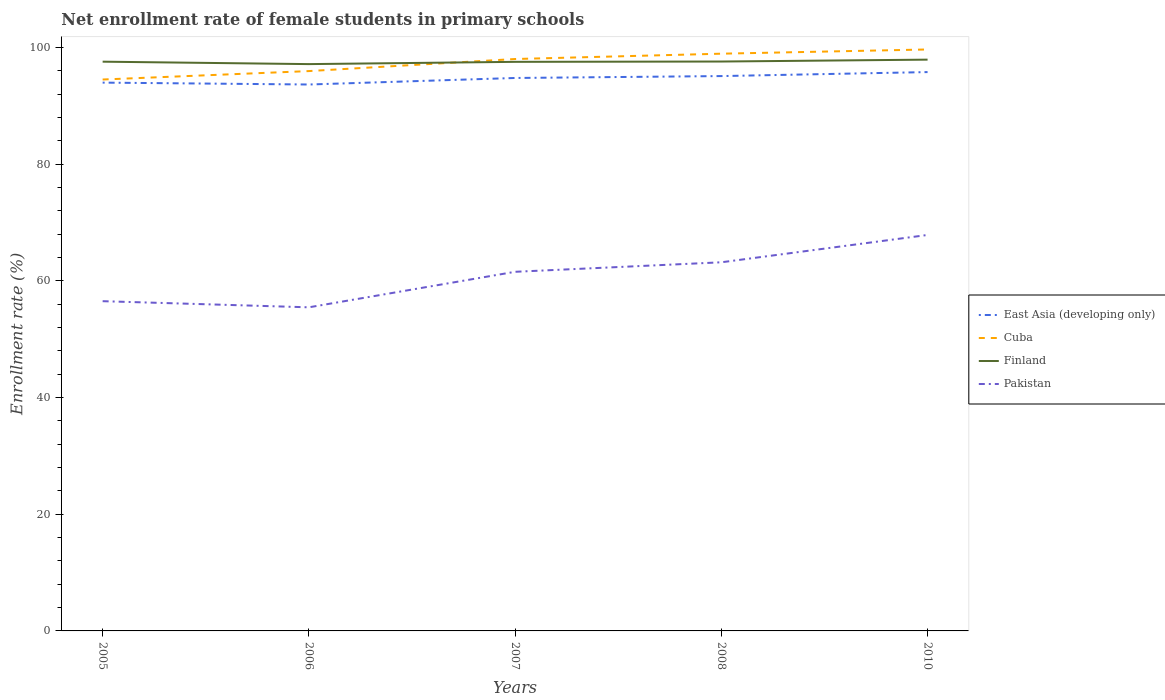Is the number of lines equal to the number of legend labels?
Provide a succinct answer. Yes. Across all years, what is the maximum net enrollment rate of female students in primary schools in Finland?
Your answer should be very brief. 97.15. In which year was the net enrollment rate of female students in primary schools in Pakistan maximum?
Offer a very short reply. 2006. What is the total net enrollment rate of female students in primary schools in Pakistan in the graph?
Ensure brevity in your answer.  -5.04. What is the difference between the highest and the second highest net enrollment rate of female students in primary schools in East Asia (developing only)?
Offer a very short reply. 2.13. What is the difference between the highest and the lowest net enrollment rate of female students in primary schools in Finland?
Your response must be concise. 3. Is the net enrollment rate of female students in primary schools in Pakistan strictly greater than the net enrollment rate of female students in primary schools in Finland over the years?
Your answer should be compact. Yes. What is the difference between two consecutive major ticks on the Y-axis?
Your answer should be compact. 20. Are the values on the major ticks of Y-axis written in scientific E-notation?
Your answer should be compact. No. Does the graph contain any zero values?
Provide a succinct answer. No. Does the graph contain grids?
Give a very brief answer. No. How many legend labels are there?
Ensure brevity in your answer.  4. How are the legend labels stacked?
Ensure brevity in your answer.  Vertical. What is the title of the graph?
Provide a succinct answer. Net enrollment rate of female students in primary schools. Does "Brazil" appear as one of the legend labels in the graph?
Give a very brief answer. No. What is the label or title of the Y-axis?
Provide a short and direct response. Enrollment rate (%). What is the Enrollment rate (%) of East Asia (developing only) in 2005?
Your answer should be very brief. 93.98. What is the Enrollment rate (%) of Cuba in 2005?
Give a very brief answer. 94.51. What is the Enrollment rate (%) in Finland in 2005?
Keep it short and to the point. 97.57. What is the Enrollment rate (%) of Pakistan in 2005?
Provide a short and direct response. 56.52. What is the Enrollment rate (%) of East Asia (developing only) in 2006?
Make the answer very short. 93.66. What is the Enrollment rate (%) in Cuba in 2006?
Give a very brief answer. 95.96. What is the Enrollment rate (%) of Finland in 2006?
Your response must be concise. 97.15. What is the Enrollment rate (%) in Pakistan in 2006?
Ensure brevity in your answer.  55.47. What is the Enrollment rate (%) in East Asia (developing only) in 2007?
Your answer should be very brief. 94.78. What is the Enrollment rate (%) of Cuba in 2007?
Your answer should be compact. 98.03. What is the Enrollment rate (%) of Finland in 2007?
Your response must be concise. 97.54. What is the Enrollment rate (%) of Pakistan in 2007?
Your answer should be very brief. 61.56. What is the Enrollment rate (%) in East Asia (developing only) in 2008?
Your response must be concise. 95.1. What is the Enrollment rate (%) of Cuba in 2008?
Your answer should be very brief. 98.94. What is the Enrollment rate (%) of Finland in 2008?
Offer a terse response. 97.6. What is the Enrollment rate (%) of Pakistan in 2008?
Offer a very short reply. 63.19. What is the Enrollment rate (%) of East Asia (developing only) in 2010?
Make the answer very short. 95.79. What is the Enrollment rate (%) of Cuba in 2010?
Your response must be concise. 99.66. What is the Enrollment rate (%) in Finland in 2010?
Provide a succinct answer. 97.92. What is the Enrollment rate (%) of Pakistan in 2010?
Make the answer very short. 67.87. Across all years, what is the maximum Enrollment rate (%) in East Asia (developing only)?
Give a very brief answer. 95.79. Across all years, what is the maximum Enrollment rate (%) in Cuba?
Offer a terse response. 99.66. Across all years, what is the maximum Enrollment rate (%) of Finland?
Give a very brief answer. 97.92. Across all years, what is the maximum Enrollment rate (%) of Pakistan?
Give a very brief answer. 67.87. Across all years, what is the minimum Enrollment rate (%) of East Asia (developing only)?
Offer a terse response. 93.66. Across all years, what is the minimum Enrollment rate (%) of Cuba?
Make the answer very short. 94.51. Across all years, what is the minimum Enrollment rate (%) of Finland?
Your answer should be compact. 97.15. Across all years, what is the minimum Enrollment rate (%) in Pakistan?
Ensure brevity in your answer.  55.47. What is the total Enrollment rate (%) in East Asia (developing only) in the graph?
Offer a terse response. 473.31. What is the total Enrollment rate (%) of Cuba in the graph?
Keep it short and to the point. 487.1. What is the total Enrollment rate (%) in Finland in the graph?
Offer a very short reply. 487.78. What is the total Enrollment rate (%) in Pakistan in the graph?
Offer a very short reply. 304.6. What is the difference between the Enrollment rate (%) of East Asia (developing only) in 2005 and that in 2006?
Provide a short and direct response. 0.32. What is the difference between the Enrollment rate (%) in Cuba in 2005 and that in 2006?
Offer a very short reply. -1.45. What is the difference between the Enrollment rate (%) of Finland in 2005 and that in 2006?
Your answer should be compact. 0.42. What is the difference between the Enrollment rate (%) of Pakistan in 2005 and that in 2006?
Ensure brevity in your answer.  1.05. What is the difference between the Enrollment rate (%) in East Asia (developing only) in 2005 and that in 2007?
Offer a terse response. -0.8. What is the difference between the Enrollment rate (%) of Cuba in 2005 and that in 2007?
Your answer should be compact. -3.51. What is the difference between the Enrollment rate (%) in Finland in 2005 and that in 2007?
Give a very brief answer. 0.03. What is the difference between the Enrollment rate (%) in Pakistan in 2005 and that in 2007?
Keep it short and to the point. -5.04. What is the difference between the Enrollment rate (%) in East Asia (developing only) in 2005 and that in 2008?
Give a very brief answer. -1.12. What is the difference between the Enrollment rate (%) in Cuba in 2005 and that in 2008?
Offer a very short reply. -4.43. What is the difference between the Enrollment rate (%) of Finland in 2005 and that in 2008?
Your answer should be compact. -0.03. What is the difference between the Enrollment rate (%) of Pakistan in 2005 and that in 2008?
Ensure brevity in your answer.  -6.67. What is the difference between the Enrollment rate (%) in East Asia (developing only) in 2005 and that in 2010?
Provide a short and direct response. -1.81. What is the difference between the Enrollment rate (%) of Cuba in 2005 and that in 2010?
Make the answer very short. -5.15. What is the difference between the Enrollment rate (%) of Finland in 2005 and that in 2010?
Give a very brief answer. -0.35. What is the difference between the Enrollment rate (%) of Pakistan in 2005 and that in 2010?
Provide a succinct answer. -11.35. What is the difference between the Enrollment rate (%) of East Asia (developing only) in 2006 and that in 2007?
Offer a terse response. -1.12. What is the difference between the Enrollment rate (%) of Cuba in 2006 and that in 2007?
Your answer should be very brief. -2.07. What is the difference between the Enrollment rate (%) in Finland in 2006 and that in 2007?
Offer a terse response. -0.39. What is the difference between the Enrollment rate (%) in Pakistan in 2006 and that in 2007?
Provide a short and direct response. -6.09. What is the difference between the Enrollment rate (%) of East Asia (developing only) in 2006 and that in 2008?
Keep it short and to the point. -1.45. What is the difference between the Enrollment rate (%) in Cuba in 2006 and that in 2008?
Offer a terse response. -2.98. What is the difference between the Enrollment rate (%) in Finland in 2006 and that in 2008?
Offer a terse response. -0.44. What is the difference between the Enrollment rate (%) in Pakistan in 2006 and that in 2008?
Provide a succinct answer. -7.72. What is the difference between the Enrollment rate (%) of East Asia (developing only) in 2006 and that in 2010?
Keep it short and to the point. -2.13. What is the difference between the Enrollment rate (%) of Cuba in 2006 and that in 2010?
Your answer should be compact. -3.7. What is the difference between the Enrollment rate (%) of Finland in 2006 and that in 2010?
Your answer should be compact. -0.77. What is the difference between the Enrollment rate (%) of Pakistan in 2006 and that in 2010?
Offer a very short reply. -12.4. What is the difference between the Enrollment rate (%) of East Asia (developing only) in 2007 and that in 2008?
Give a very brief answer. -0.33. What is the difference between the Enrollment rate (%) of Cuba in 2007 and that in 2008?
Your response must be concise. -0.91. What is the difference between the Enrollment rate (%) in Finland in 2007 and that in 2008?
Your answer should be very brief. -0.05. What is the difference between the Enrollment rate (%) in Pakistan in 2007 and that in 2008?
Give a very brief answer. -1.63. What is the difference between the Enrollment rate (%) of East Asia (developing only) in 2007 and that in 2010?
Your response must be concise. -1.01. What is the difference between the Enrollment rate (%) of Cuba in 2007 and that in 2010?
Give a very brief answer. -1.64. What is the difference between the Enrollment rate (%) in Finland in 2007 and that in 2010?
Provide a short and direct response. -0.38. What is the difference between the Enrollment rate (%) in Pakistan in 2007 and that in 2010?
Make the answer very short. -6.31. What is the difference between the Enrollment rate (%) of East Asia (developing only) in 2008 and that in 2010?
Provide a short and direct response. -0.68. What is the difference between the Enrollment rate (%) in Cuba in 2008 and that in 2010?
Your answer should be compact. -0.72. What is the difference between the Enrollment rate (%) in Finland in 2008 and that in 2010?
Make the answer very short. -0.32. What is the difference between the Enrollment rate (%) in Pakistan in 2008 and that in 2010?
Provide a succinct answer. -4.68. What is the difference between the Enrollment rate (%) of East Asia (developing only) in 2005 and the Enrollment rate (%) of Cuba in 2006?
Ensure brevity in your answer.  -1.98. What is the difference between the Enrollment rate (%) of East Asia (developing only) in 2005 and the Enrollment rate (%) of Finland in 2006?
Your response must be concise. -3.17. What is the difference between the Enrollment rate (%) of East Asia (developing only) in 2005 and the Enrollment rate (%) of Pakistan in 2006?
Offer a terse response. 38.51. What is the difference between the Enrollment rate (%) of Cuba in 2005 and the Enrollment rate (%) of Finland in 2006?
Ensure brevity in your answer.  -2.64. What is the difference between the Enrollment rate (%) in Cuba in 2005 and the Enrollment rate (%) in Pakistan in 2006?
Offer a terse response. 39.05. What is the difference between the Enrollment rate (%) of Finland in 2005 and the Enrollment rate (%) of Pakistan in 2006?
Give a very brief answer. 42.1. What is the difference between the Enrollment rate (%) of East Asia (developing only) in 2005 and the Enrollment rate (%) of Cuba in 2007?
Keep it short and to the point. -4.05. What is the difference between the Enrollment rate (%) in East Asia (developing only) in 2005 and the Enrollment rate (%) in Finland in 2007?
Offer a very short reply. -3.56. What is the difference between the Enrollment rate (%) of East Asia (developing only) in 2005 and the Enrollment rate (%) of Pakistan in 2007?
Give a very brief answer. 32.43. What is the difference between the Enrollment rate (%) in Cuba in 2005 and the Enrollment rate (%) in Finland in 2007?
Give a very brief answer. -3.03. What is the difference between the Enrollment rate (%) of Cuba in 2005 and the Enrollment rate (%) of Pakistan in 2007?
Offer a terse response. 32.96. What is the difference between the Enrollment rate (%) of Finland in 2005 and the Enrollment rate (%) of Pakistan in 2007?
Provide a succinct answer. 36.01. What is the difference between the Enrollment rate (%) in East Asia (developing only) in 2005 and the Enrollment rate (%) in Cuba in 2008?
Your response must be concise. -4.96. What is the difference between the Enrollment rate (%) of East Asia (developing only) in 2005 and the Enrollment rate (%) of Finland in 2008?
Offer a very short reply. -3.61. What is the difference between the Enrollment rate (%) of East Asia (developing only) in 2005 and the Enrollment rate (%) of Pakistan in 2008?
Make the answer very short. 30.8. What is the difference between the Enrollment rate (%) in Cuba in 2005 and the Enrollment rate (%) in Finland in 2008?
Provide a short and direct response. -3.08. What is the difference between the Enrollment rate (%) in Cuba in 2005 and the Enrollment rate (%) in Pakistan in 2008?
Make the answer very short. 31.33. What is the difference between the Enrollment rate (%) of Finland in 2005 and the Enrollment rate (%) of Pakistan in 2008?
Offer a very short reply. 34.39. What is the difference between the Enrollment rate (%) in East Asia (developing only) in 2005 and the Enrollment rate (%) in Cuba in 2010?
Your answer should be very brief. -5.68. What is the difference between the Enrollment rate (%) of East Asia (developing only) in 2005 and the Enrollment rate (%) of Finland in 2010?
Ensure brevity in your answer.  -3.94. What is the difference between the Enrollment rate (%) of East Asia (developing only) in 2005 and the Enrollment rate (%) of Pakistan in 2010?
Your answer should be very brief. 26.11. What is the difference between the Enrollment rate (%) in Cuba in 2005 and the Enrollment rate (%) in Finland in 2010?
Keep it short and to the point. -3.41. What is the difference between the Enrollment rate (%) in Cuba in 2005 and the Enrollment rate (%) in Pakistan in 2010?
Give a very brief answer. 26.64. What is the difference between the Enrollment rate (%) of Finland in 2005 and the Enrollment rate (%) of Pakistan in 2010?
Keep it short and to the point. 29.7. What is the difference between the Enrollment rate (%) in East Asia (developing only) in 2006 and the Enrollment rate (%) in Cuba in 2007?
Your response must be concise. -4.37. What is the difference between the Enrollment rate (%) of East Asia (developing only) in 2006 and the Enrollment rate (%) of Finland in 2007?
Provide a succinct answer. -3.88. What is the difference between the Enrollment rate (%) in East Asia (developing only) in 2006 and the Enrollment rate (%) in Pakistan in 2007?
Offer a terse response. 32.1. What is the difference between the Enrollment rate (%) of Cuba in 2006 and the Enrollment rate (%) of Finland in 2007?
Offer a terse response. -1.58. What is the difference between the Enrollment rate (%) in Cuba in 2006 and the Enrollment rate (%) in Pakistan in 2007?
Keep it short and to the point. 34.4. What is the difference between the Enrollment rate (%) in Finland in 2006 and the Enrollment rate (%) in Pakistan in 2007?
Your answer should be very brief. 35.6. What is the difference between the Enrollment rate (%) in East Asia (developing only) in 2006 and the Enrollment rate (%) in Cuba in 2008?
Provide a succinct answer. -5.28. What is the difference between the Enrollment rate (%) of East Asia (developing only) in 2006 and the Enrollment rate (%) of Finland in 2008?
Make the answer very short. -3.94. What is the difference between the Enrollment rate (%) in East Asia (developing only) in 2006 and the Enrollment rate (%) in Pakistan in 2008?
Your response must be concise. 30.47. What is the difference between the Enrollment rate (%) in Cuba in 2006 and the Enrollment rate (%) in Finland in 2008?
Keep it short and to the point. -1.64. What is the difference between the Enrollment rate (%) in Cuba in 2006 and the Enrollment rate (%) in Pakistan in 2008?
Provide a short and direct response. 32.77. What is the difference between the Enrollment rate (%) of Finland in 2006 and the Enrollment rate (%) of Pakistan in 2008?
Keep it short and to the point. 33.97. What is the difference between the Enrollment rate (%) in East Asia (developing only) in 2006 and the Enrollment rate (%) in Cuba in 2010?
Provide a succinct answer. -6.01. What is the difference between the Enrollment rate (%) in East Asia (developing only) in 2006 and the Enrollment rate (%) in Finland in 2010?
Provide a succinct answer. -4.26. What is the difference between the Enrollment rate (%) in East Asia (developing only) in 2006 and the Enrollment rate (%) in Pakistan in 2010?
Your answer should be compact. 25.79. What is the difference between the Enrollment rate (%) of Cuba in 2006 and the Enrollment rate (%) of Finland in 2010?
Your answer should be compact. -1.96. What is the difference between the Enrollment rate (%) in Cuba in 2006 and the Enrollment rate (%) in Pakistan in 2010?
Keep it short and to the point. 28.09. What is the difference between the Enrollment rate (%) in Finland in 2006 and the Enrollment rate (%) in Pakistan in 2010?
Your answer should be very brief. 29.28. What is the difference between the Enrollment rate (%) in East Asia (developing only) in 2007 and the Enrollment rate (%) in Cuba in 2008?
Keep it short and to the point. -4.16. What is the difference between the Enrollment rate (%) in East Asia (developing only) in 2007 and the Enrollment rate (%) in Finland in 2008?
Provide a succinct answer. -2.82. What is the difference between the Enrollment rate (%) of East Asia (developing only) in 2007 and the Enrollment rate (%) of Pakistan in 2008?
Offer a terse response. 31.59. What is the difference between the Enrollment rate (%) in Cuba in 2007 and the Enrollment rate (%) in Finland in 2008?
Keep it short and to the point. 0.43. What is the difference between the Enrollment rate (%) in Cuba in 2007 and the Enrollment rate (%) in Pakistan in 2008?
Your response must be concise. 34.84. What is the difference between the Enrollment rate (%) in Finland in 2007 and the Enrollment rate (%) in Pakistan in 2008?
Provide a succinct answer. 34.36. What is the difference between the Enrollment rate (%) in East Asia (developing only) in 2007 and the Enrollment rate (%) in Cuba in 2010?
Provide a succinct answer. -4.89. What is the difference between the Enrollment rate (%) in East Asia (developing only) in 2007 and the Enrollment rate (%) in Finland in 2010?
Provide a short and direct response. -3.14. What is the difference between the Enrollment rate (%) of East Asia (developing only) in 2007 and the Enrollment rate (%) of Pakistan in 2010?
Your response must be concise. 26.91. What is the difference between the Enrollment rate (%) of Cuba in 2007 and the Enrollment rate (%) of Finland in 2010?
Ensure brevity in your answer.  0.11. What is the difference between the Enrollment rate (%) of Cuba in 2007 and the Enrollment rate (%) of Pakistan in 2010?
Make the answer very short. 30.16. What is the difference between the Enrollment rate (%) in Finland in 2007 and the Enrollment rate (%) in Pakistan in 2010?
Give a very brief answer. 29.67. What is the difference between the Enrollment rate (%) in East Asia (developing only) in 2008 and the Enrollment rate (%) in Cuba in 2010?
Your answer should be compact. -4.56. What is the difference between the Enrollment rate (%) of East Asia (developing only) in 2008 and the Enrollment rate (%) of Finland in 2010?
Keep it short and to the point. -2.82. What is the difference between the Enrollment rate (%) in East Asia (developing only) in 2008 and the Enrollment rate (%) in Pakistan in 2010?
Provide a succinct answer. 27.23. What is the difference between the Enrollment rate (%) in Cuba in 2008 and the Enrollment rate (%) in Finland in 2010?
Your answer should be very brief. 1.02. What is the difference between the Enrollment rate (%) in Cuba in 2008 and the Enrollment rate (%) in Pakistan in 2010?
Offer a very short reply. 31.07. What is the difference between the Enrollment rate (%) in Finland in 2008 and the Enrollment rate (%) in Pakistan in 2010?
Offer a very short reply. 29.73. What is the average Enrollment rate (%) in East Asia (developing only) per year?
Keep it short and to the point. 94.66. What is the average Enrollment rate (%) in Cuba per year?
Provide a succinct answer. 97.42. What is the average Enrollment rate (%) in Finland per year?
Give a very brief answer. 97.56. What is the average Enrollment rate (%) of Pakistan per year?
Offer a very short reply. 60.92. In the year 2005, what is the difference between the Enrollment rate (%) in East Asia (developing only) and Enrollment rate (%) in Cuba?
Offer a terse response. -0.53. In the year 2005, what is the difference between the Enrollment rate (%) in East Asia (developing only) and Enrollment rate (%) in Finland?
Offer a very short reply. -3.59. In the year 2005, what is the difference between the Enrollment rate (%) in East Asia (developing only) and Enrollment rate (%) in Pakistan?
Your answer should be compact. 37.46. In the year 2005, what is the difference between the Enrollment rate (%) in Cuba and Enrollment rate (%) in Finland?
Give a very brief answer. -3.06. In the year 2005, what is the difference between the Enrollment rate (%) of Cuba and Enrollment rate (%) of Pakistan?
Make the answer very short. 38. In the year 2005, what is the difference between the Enrollment rate (%) of Finland and Enrollment rate (%) of Pakistan?
Give a very brief answer. 41.05. In the year 2006, what is the difference between the Enrollment rate (%) in East Asia (developing only) and Enrollment rate (%) in Cuba?
Provide a short and direct response. -2.3. In the year 2006, what is the difference between the Enrollment rate (%) of East Asia (developing only) and Enrollment rate (%) of Finland?
Offer a very short reply. -3.5. In the year 2006, what is the difference between the Enrollment rate (%) of East Asia (developing only) and Enrollment rate (%) of Pakistan?
Ensure brevity in your answer.  38.19. In the year 2006, what is the difference between the Enrollment rate (%) in Cuba and Enrollment rate (%) in Finland?
Keep it short and to the point. -1.19. In the year 2006, what is the difference between the Enrollment rate (%) of Cuba and Enrollment rate (%) of Pakistan?
Offer a terse response. 40.49. In the year 2006, what is the difference between the Enrollment rate (%) of Finland and Enrollment rate (%) of Pakistan?
Your answer should be compact. 41.69. In the year 2007, what is the difference between the Enrollment rate (%) in East Asia (developing only) and Enrollment rate (%) in Cuba?
Provide a short and direct response. -3.25. In the year 2007, what is the difference between the Enrollment rate (%) of East Asia (developing only) and Enrollment rate (%) of Finland?
Provide a succinct answer. -2.76. In the year 2007, what is the difference between the Enrollment rate (%) in East Asia (developing only) and Enrollment rate (%) in Pakistan?
Ensure brevity in your answer.  33.22. In the year 2007, what is the difference between the Enrollment rate (%) in Cuba and Enrollment rate (%) in Finland?
Offer a very short reply. 0.49. In the year 2007, what is the difference between the Enrollment rate (%) in Cuba and Enrollment rate (%) in Pakistan?
Keep it short and to the point. 36.47. In the year 2007, what is the difference between the Enrollment rate (%) in Finland and Enrollment rate (%) in Pakistan?
Offer a terse response. 35.98. In the year 2008, what is the difference between the Enrollment rate (%) of East Asia (developing only) and Enrollment rate (%) of Cuba?
Provide a succinct answer. -3.84. In the year 2008, what is the difference between the Enrollment rate (%) in East Asia (developing only) and Enrollment rate (%) in Finland?
Your answer should be very brief. -2.49. In the year 2008, what is the difference between the Enrollment rate (%) of East Asia (developing only) and Enrollment rate (%) of Pakistan?
Offer a very short reply. 31.92. In the year 2008, what is the difference between the Enrollment rate (%) in Cuba and Enrollment rate (%) in Finland?
Provide a short and direct response. 1.34. In the year 2008, what is the difference between the Enrollment rate (%) of Cuba and Enrollment rate (%) of Pakistan?
Your response must be concise. 35.75. In the year 2008, what is the difference between the Enrollment rate (%) of Finland and Enrollment rate (%) of Pakistan?
Keep it short and to the point. 34.41. In the year 2010, what is the difference between the Enrollment rate (%) of East Asia (developing only) and Enrollment rate (%) of Cuba?
Provide a succinct answer. -3.88. In the year 2010, what is the difference between the Enrollment rate (%) of East Asia (developing only) and Enrollment rate (%) of Finland?
Keep it short and to the point. -2.13. In the year 2010, what is the difference between the Enrollment rate (%) of East Asia (developing only) and Enrollment rate (%) of Pakistan?
Offer a terse response. 27.92. In the year 2010, what is the difference between the Enrollment rate (%) in Cuba and Enrollment rate (%) in Finland?
Provide a succinct answer. 1.74. In the year 2010, what is the difference between the Enrollment rate (%) in Cuba and Enrollment rate (%) in Pakistan?
Ensure brevity in your answer.  31.79. In the year 2010, what is the difference between the Enrollment rate (%) in Finland and Enrollment rate (%) in Pakistan?
Make the answer very short. 30.05. What is the ratio of the Enrollment rate (%) in Cuba in 2005 to that in 2006?
Provide a succinct answer. 0.98. What is the ratio of the Enrollment rate (%) of Pakistan in 2005 to that in 2006?
Ensure brevity in your answer.  1.02. What is the ratio of the Enrollment rate (%) in Cuba in 2005 to that in 2007?
Your response must be concise. 0.96. What is the ratio of the Enrollment rate (%) in Pakistan in 2005 to that in 2007?
Keep it short and to the point. 0.92. What is the ratio of the Enrollment rate (%) of East Asia (developing only) in 2005 to that in 2008?
Provide a succinct answer. 0.99. What is the ratio of the Enrollment rate (%) of Cuba in 2005 to that in 2008?
Provide a short and direct response. 0.96. What is the ratio of the Enrollment rate (%) in Pakistan in 2005 to that in 2008?
Keep it short and to the point. 0.89. What is the ratio of the Enrollment rate (%) of East Asia (developing only) in 2005 to that in 2010?
Make the answer very short. 0.98. What is the ratio of the Enrollment rate (%) in Cuba in 2005 to that in 2010?
Your answer should be very brief. 0.95. What is the ratio of the Enrollment rate (%) of Finland in 2005 to that in 2010?
Your answer should be compact. 1. What is the ratio of the Enrollment rate (%) of Pakistan in 2005 to that in 2010?
Make the answer very short. 0.83. What is the ratio of the Enrollment rate (%) of East Asia (developing only) in 2006 to that in 2007?
Keep it short and to the point. 0.99. What is the ratio of the Enrollment rate (%) in Cuba in 2006 to that in 2007?
Keep it short and to the point. 0.98. What is the ratio of the Enrollment rate (%) in Pakistan in 2006 to that in 2007?
Your answer should be compact. 0.9. What is the ratio of the Enrollment rate (%) in East Asia (developing only) in 2006 to that in 2008?
Provide a succinct answer. 0.98. What is the ratio of the Enrollment rate (%) in Cuba in 2006 to that in 2008?
Your answer should be very brief. 0.97. What is the ratio of the Enrollment rate (%) in Pakistan in 2006 to that in 2008?
Your answer should be compact. 0.88. What is the ratio of the Enrollment rate (%) in East Asia (developing only) in 2006 to that in 2010?
Provide a succinct answer. 0.98. What is the ratio of the Enrollment rate (%) in Cuba in 2006 to that in 2010?
Give a very brief answer. 0.96. What is the ratio of the Enrollment rate (%) of Pakistan in 2006 to that in 2010?
Make the answer very short. 0.82. What is the ratio of the Enrollment rate (%) of East Asia (developing only) in 2007 to that in 2008?
Ensure brevity in your answer.  1. What is the ratio of the Enrollment rate (%) in Cuba in 2007 to that in 2008?
Offer a terse response. 0.99. What is the ratio of the Enrollment rate (%) of Finland in 2007 to that in 2008?
Your answer should be very brief. 1. What is the ratio of the Enrollment rate (%) of Pakistan in 2007 to that in 2008?
Offer a terse response. 0.97. What is the ratio of the Enrollment rate (%) of East Asia (developing only) in 2007 to that in 2010?
Make the answer very short. 0.99. What is the ratio of the Enrollment rate (%) of Cuba in 2007 to that in 2010?
Your answer should be compact. 0.98. What is the ratio of the Enrollment rate (%) of Finland in 2007 to that in 2010?
Provide a short and direct response. 1. What is the ratio of the Enrollment rate (%) in Pakistan in 2007 to that in 2010?
Provide a succinct answer. 0.91. What is the ratio of the Enrollment rate (%) in Cuba in 2008 to that in 2010?
Make the answer very short. 0.99. What is the ratio of the Enrollment rate (%) in Finland in 2008 to that in 2010?
Provide a succinct answer. 1. What is the difference between the highest and the second highest Enrollment rate (%) of East Asia (developing only)?
Offer a terse response. 0.68. What is the difference between the highest and the second highest Enrollment rate (%) of Cuba?
Provide a short and direct response. 0.72. What is the difference between the highest and the second highest Enrollment rate (%) of Finland?
Your answer should be very brief. 0.32. What is the difference between the highest and the second highest Enrollment rate (%) of Pakistan?
Provide a succinct answer. 4.68. What is the difference between the highest and the lowest Enrollment rate (%) of East Asia (developing only)?
Your answer should be compact. 2.13. What is the difference between the highest and the lowest Enrollment rate (%) in Cuba?
Offer a terse response. 5.15. What is the difference between the highest and the lowest Enrollment rate (%) in Finland?
Your response must be concise. 0.77. What is the difference between the highest and the lowest Enrollment rate (%) in Pakistan?
Give a very brief answer. 12.4. 